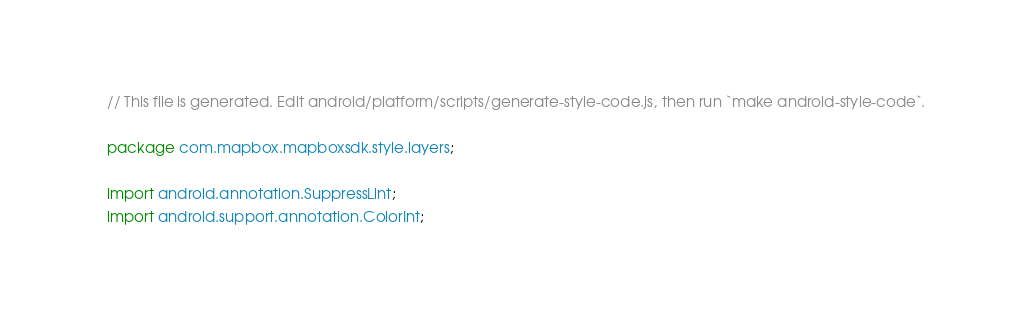Convert code to text. <code><loc_0><loc_0><loc_500><loc_500><_Java_>// This file is generated. Edit android/platform/scripts/generate-style-code.js, then run `make android-style-code`.

package com.mapbox.mapboxsdk.style.layers;

import android.annotation.SuppressLint;
import android.support.annotation.ColorInt;
</code> 